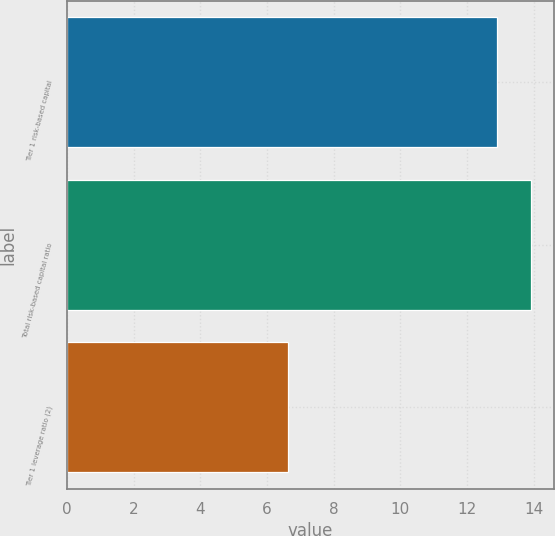Convert chart to OTSL. <chart><loc_0><loc_0><loc_500><loc_500><bar_chart><fcel>Tier 1 risk-based capital<fcel>Total risk-based capital ratio<fcel>Tier 1 leverage ratio (2)<nl><fcel>12.91<fcel>13.92<fcel>6.64<nl></chart> 